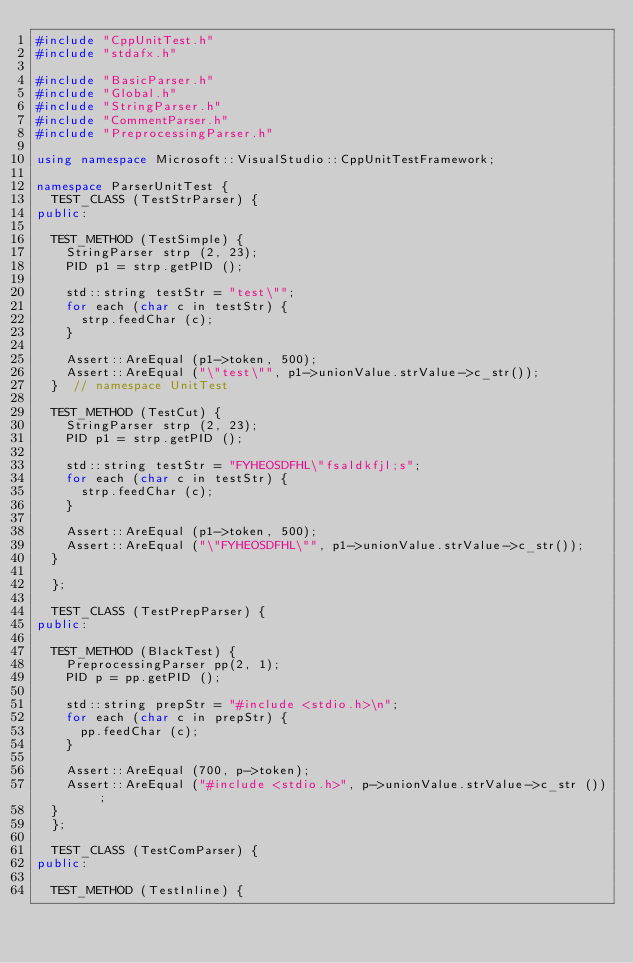Convert code to text. <code><loc_0><loc_0><loc_500><loc_500><_C++_>#include "CppUnitTest.h"
#include "stdafx.h"

#include "BasicParser.h"
#include "Global.h"
#include "StringParser.h"
#include "CommentParser.h"
#include "PreprocessingParser.h"

using namespace Microsoft::VisualStudio::CppUnitTestFramework;

namespace ParserUnitTest {
  TEST_CLASS (TestStrParser) {
public:

  TEST_METHOD (TestSimple) {
    StringParser strp (2, 23);
    PID p1 = strp.getPID ();

    std::string testStr = "test\"";
    for each (char c in testStr) {
      strp.feedChar (c);
    }

    Assert::AreEqual (p1->token, 500);
    Assert::AreEqual ("\"test\"", p1->unionValue.strValue->c_str());
  }  // namespace UnitTest

  TEST_METHOD (TestCut) {
    StringParser strp (2, 23);
    PID p1 = strp.getPID ();

    std::string testStr = "FYHEOSDFHL\"fsaldkfjl;s";
    for each (char c in testStr) {
      strp.feedChar (c);
    }

    Assert::AreEqual (p1->token, 500);
    Assert::AreEqual ("\"FYHEOSDFHL\"", p1->unionValue.strValue->c_str());
  }

  };

  TEST_CLASS (TestPrepParser) {
public:

  TEST_METHOD (BlackTest) {
    PreprocessingParser pp(2, 1);
    PID p = pp.getPID ();

    std::string prepStr = "#include <stdio.h>\n";
    for each (char c in prepStr) {
      pp.feedChar (c);
    }

    Assert::AreEqual (700, p->token);
    Assert::AreEqual ("#include <stdio.h>", p->unionValue.strValue->c_str ());
  }
  };

  TEST_CLASS (TestComParser) {
public:

  TEST_METHOD (TestInline) {</code> 